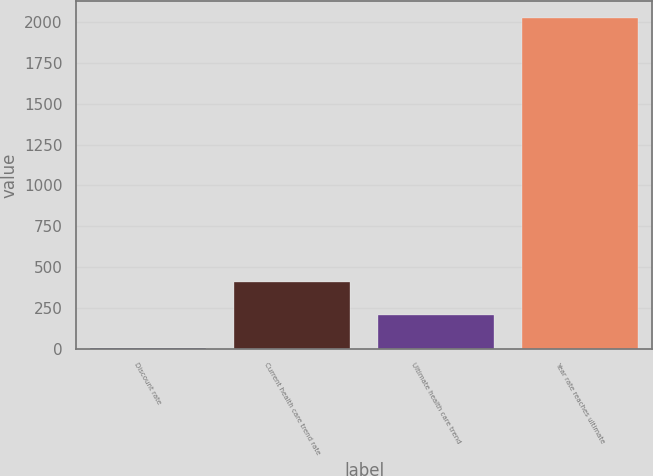<chart> <loc_0><loc_0><loc_500><loc_500><bar_chart><fcel>Discount rate<fcel>Current health care trend rate<fcel>Ultimate health care trend<fcel>Year rate reaches ultimate<nl><fcel>3.35<fcel>408.29<fcel>205.82<fcel>2028<nl></chart> 